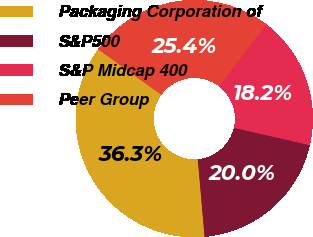Convert chart to OTSL. <chart><loc_0><loc_0><loc_500><loc_500><pie_chart><fcel>Packaging Corporation of<fcel>S&P500<fcel>S&P Midcap 400<fcel>Peer Group<nl><fcel>36.32%<fcel>20.03%<fcel>18.22%<fcel>25.42%<nl></chart> 